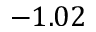<formula> <loc_0><loc_0><loc_500><loc_500>- 1 . 0 2</formula> 